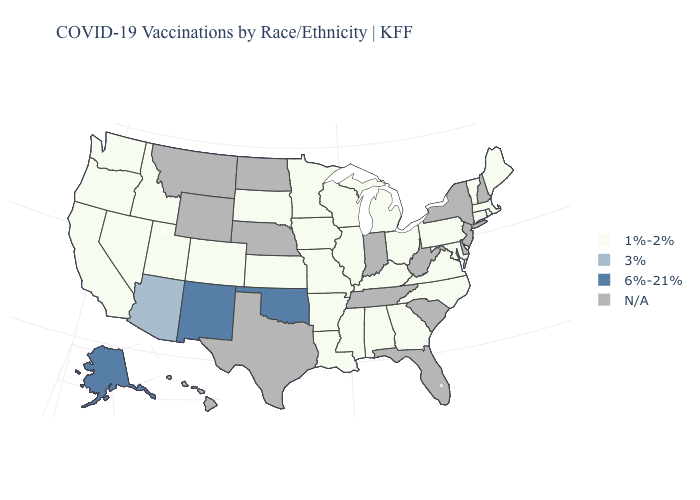Does Georgia have the lowest value in the South?
Give a very brief answer. Yes. Which states have the highest value in the USA?
Concise answer only. Alaska, New Mexico, Oklahoma. Does Nevada have the lowest value in the West?
Give a very brief answer. Yes. How many symbols are there in the legend?
Answer briefly. 4. Name the states that have a value in the range 6%-21%?
Keep it brief. Alaska, New Mexico, Oklahoma. Name the states that have a value in the range 6%-21%?
Write a very short answer. Alaska, New Mexico, Oklahoma. Name the states that have a value in the range 1%-2%?
Concise answer only. Alabama, Arkansas, California, Colorado, Connecticut, Georgia, Idaho, Illinois, Iowa, Kansas, Kentucky, Louisiana, Maine, Maryland, Massachusetts, Michigan, Minnesota, Mississippi, Missouri, Nevada, North Carolina, Ohio, Oregon, Pennsylvania, Rhode Island, South Dakota, Utah, Vermont, Virginia, Washington, Wisconsin. Name the states that have a value in the range 3%?
Be succinct. Arizona. Does the map have missing data?
Quick response, please. Yes. What is the lowest value in states that border West Virginia?
Give a very brief answer. 1%-2%. Which states hav the highest value in the South?
Quick response, please. Oklahoma. Name the states that have a value in the range 1%-2%?
Write a very short answer. Alabama, Arkansas, California, Colorado, Connecticut, Georgia, Idaho, Illinois, Iowa, Kansas, Kentucky, Louisiana, Maine, Maryland, Massachusetts, Michigan, Minnesota, Mississippi, Missouri, Nevada, North Carolina, Ohio, Oregon, Pennsylvania, Rhode Island, South Dakota, Utah, Vermont, Virginia, Washington, Wisconsin. Which states have the lowest value in the South?
Quick response, please. Alabama, Arkansas, Georgia, Kentucky, Louisiana, Maryland, Mississippi, North Carolina, Virginia. Which states hav the highest value in the Northeast?
Give a very brief answer. Connecticut, Maine, Massachusetts, Pennsylvania, Rhode Island, Vermont. 